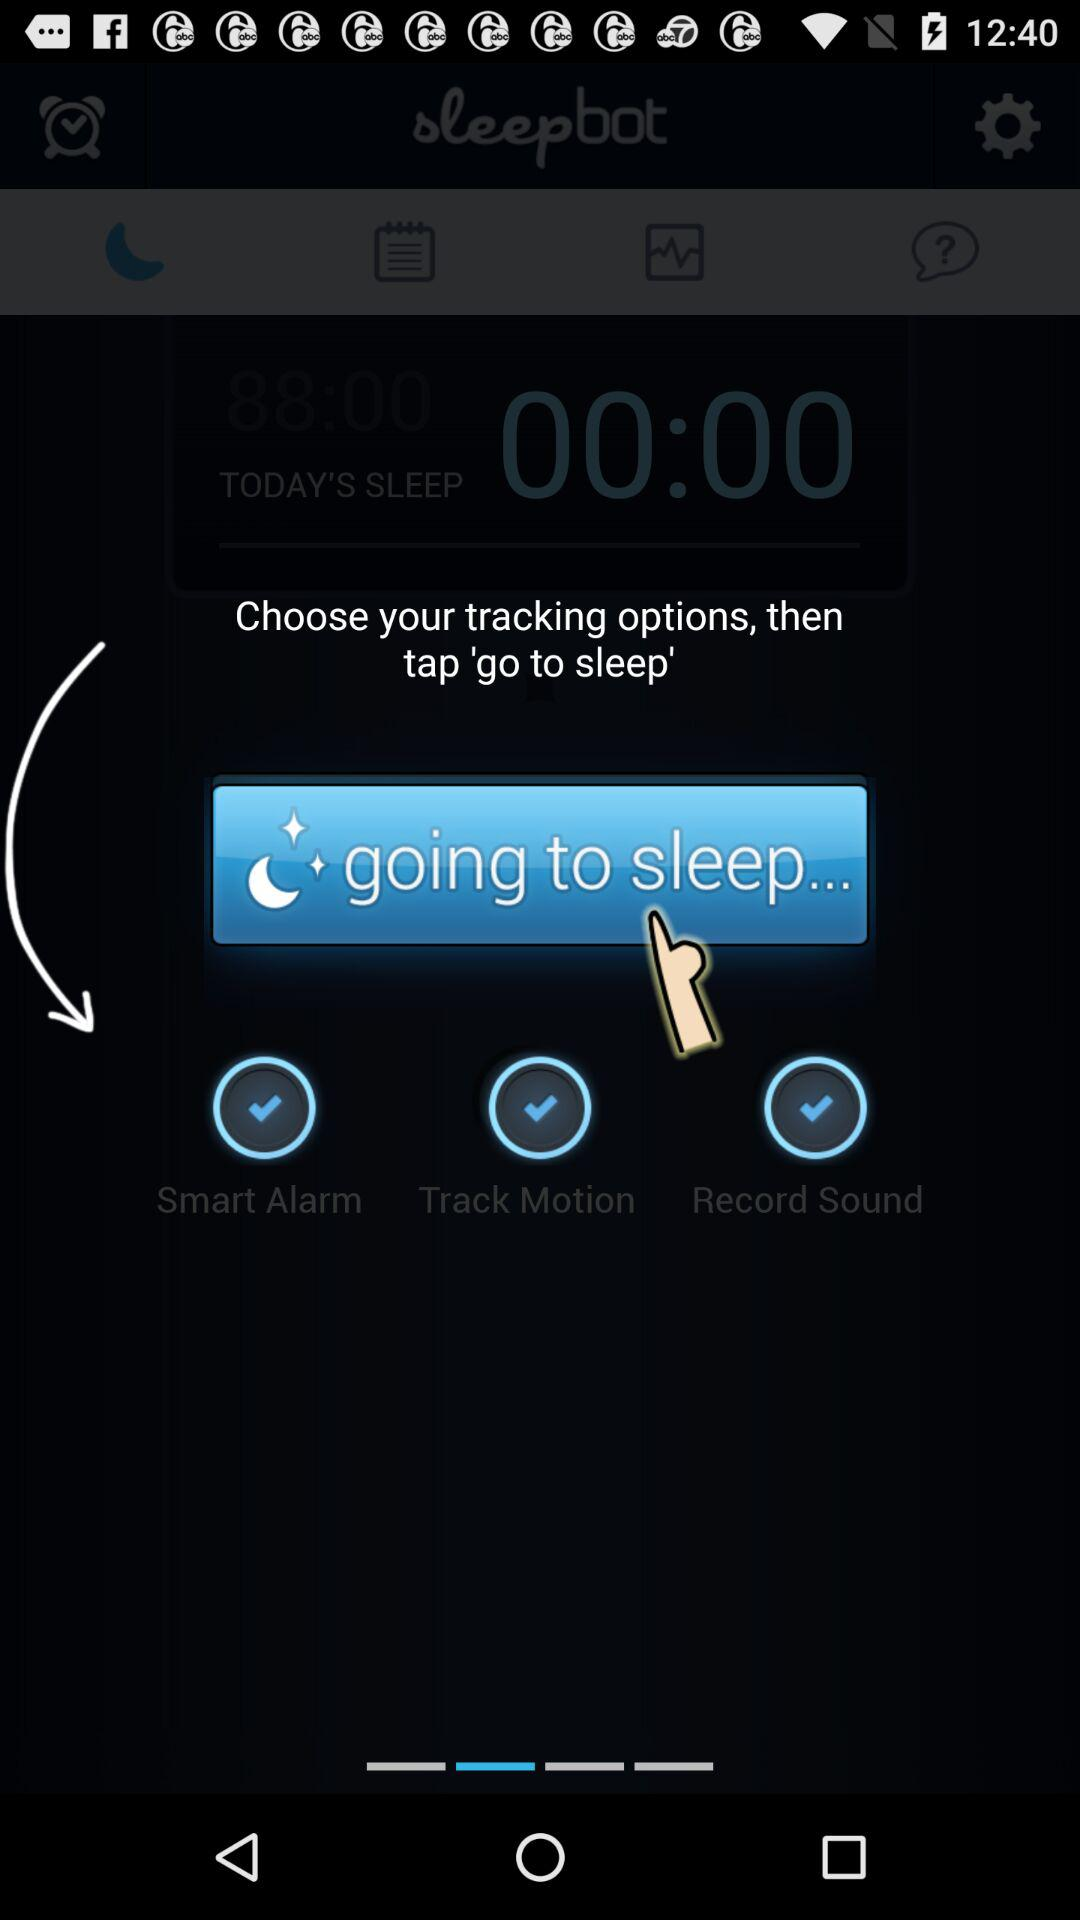How many tracking options are there?
Answer the question using a single word or phrase. 3 